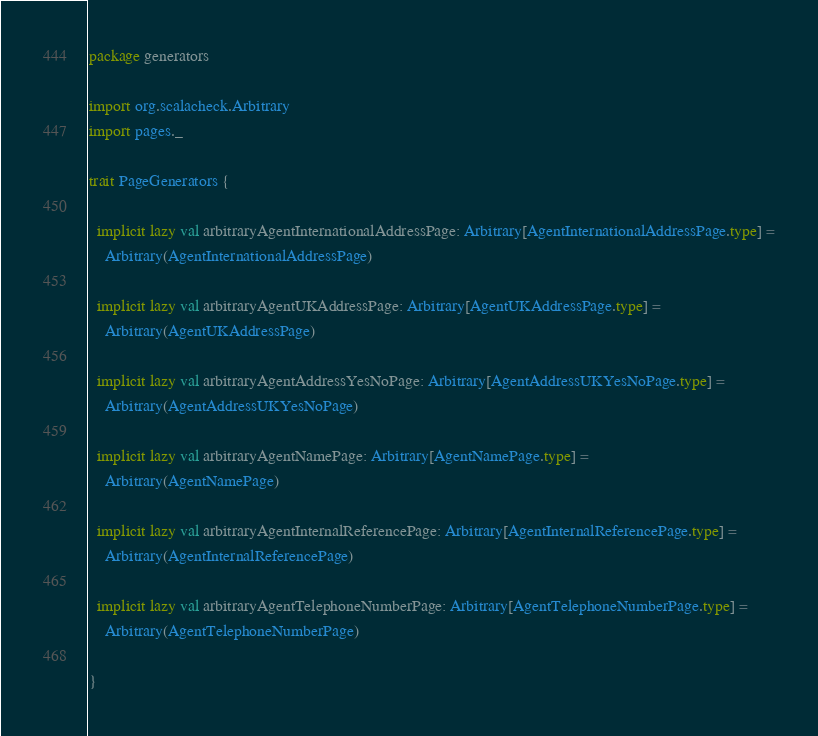<code> <loc_0><loc_0><loc_500><loc_500><_Scala_>package generators

import org.scalacheck.Arbitrary
import pages._

trait PageGenerators {

  implicit lazy val arbitraryAgentInternationalAddressPage: Arbitrary[AgentInternationalAddressPage.type] =
    Arbitrary(AgentInternationalAddressPage)

  implicit lazy val arbitraryAgentUKAddressPage: Arbitrary[AgentUKAddressPage.type] =
    Arbitrary(AgentUKAddressPage)

  implicit lazy val arbitraryAgentAddressYesNoPage: Arbitrary[AgentAddressUKYesNoPage.type] =
    Arbitrary(AgentAddressUKYesNoPage)

  implicit lazy val arbitraryAgentNamePage: Arbitrary[AgentNamePage.type] =
    Arbitrary(AgentNamePage)

  implicit lazy val arbitraryAgentInternalReferencePage: Arbitrary[AgentInternalReferencePage.type] =
    Arbitrary(AgentInternalReferencePage)

  implicit lazy val arbitraryAgentTelephoneNumberPage: Arbitrary[AgentTelephoneNumberPage.type] =
    Arbitrary(AgentTelephoneNumberPage)

}
</code> 